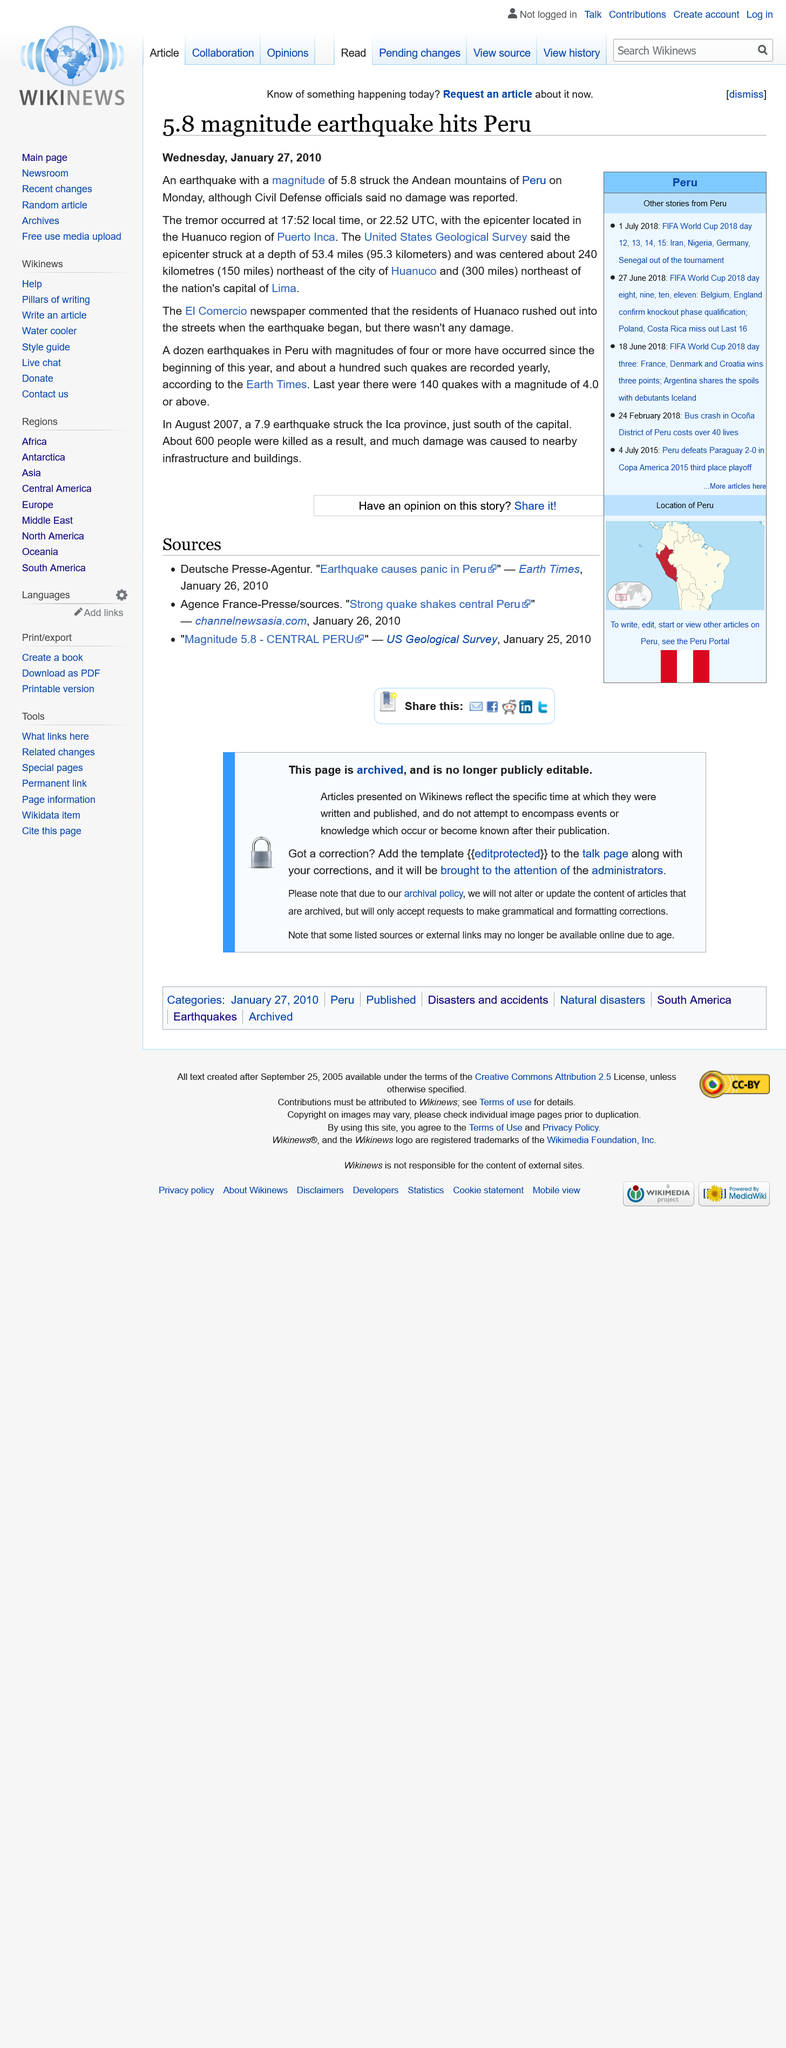Give some essential details in this illustration. In 2007, a devastating earthquake of magnitude 7.9 hit Peru, causing widespread damage and loss of life. The earthquake that hit Peru in 2010 had a magnitude of 5.8, according to reports. On Monday, January 25th, 2010, the earthquake hit Peru. 